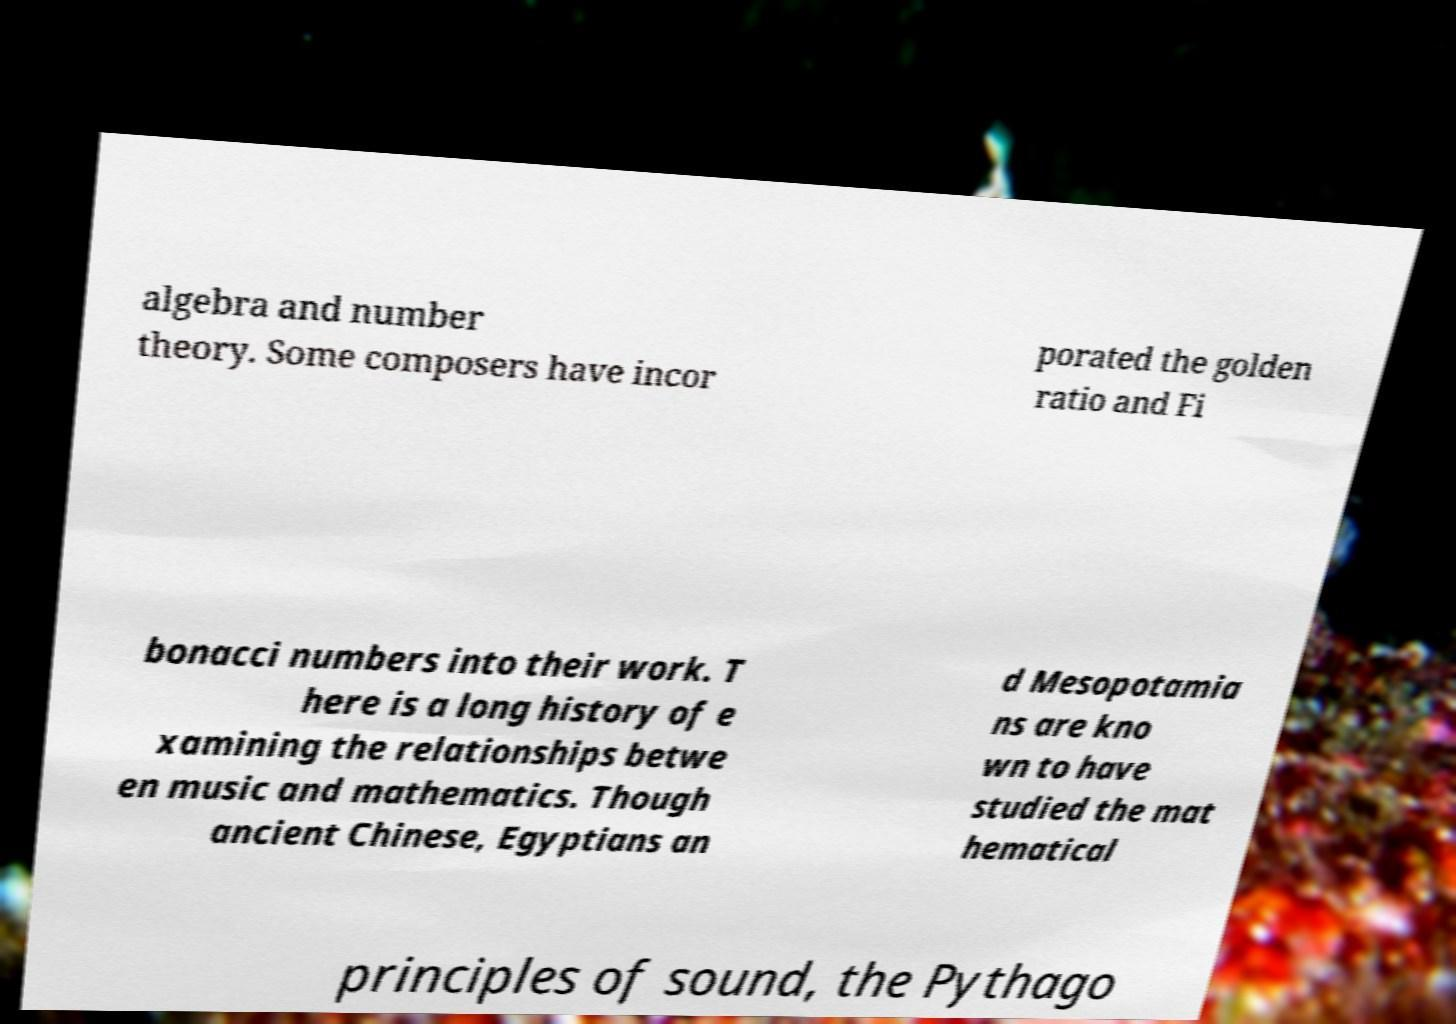There's text embedded in this image that I need extracted. Can you transcribe it verbatim? algebra and number theory. Some composers have incor porated the golden ratio and Fi bonacci numbers into their work. T here is a long history of e xamining the relationships betwe en music and mathematics. Though ancient Chinese, Egyptians an d Mesopotamia ns are kno wn to have studied the mat hematical principles of sound, the Pythago 